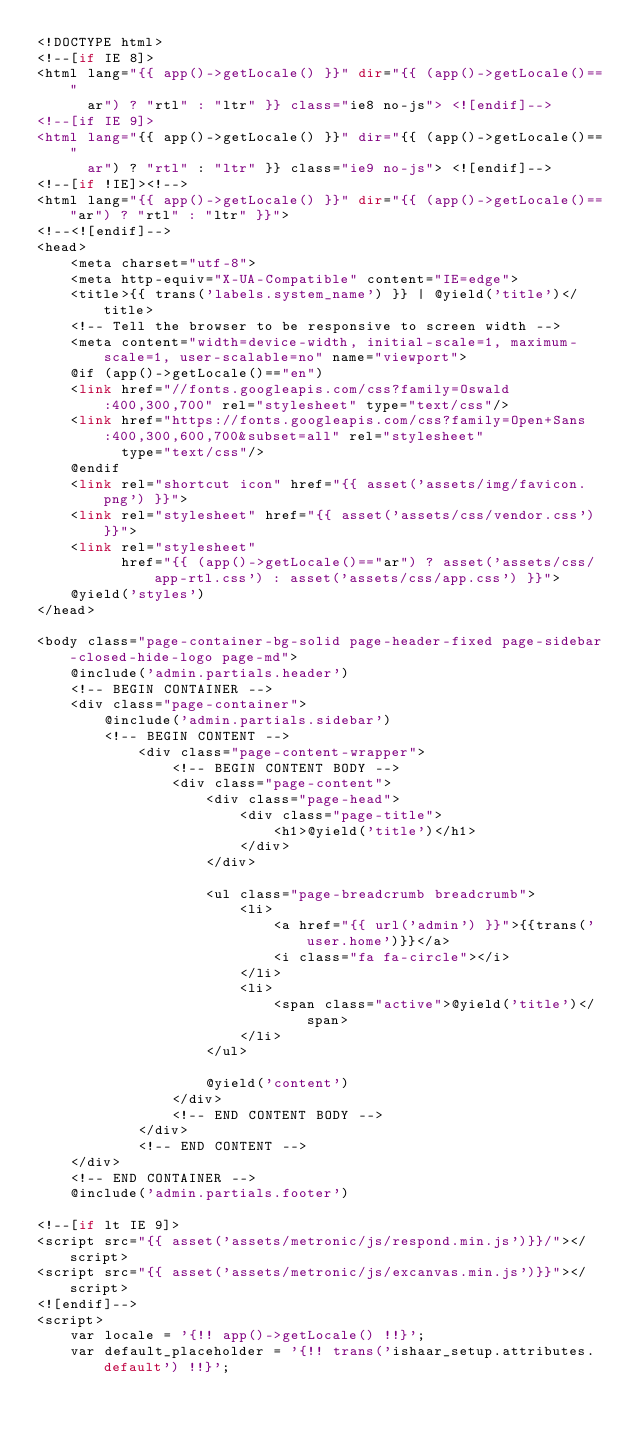<code> <loc_0><loc_0><loc_500><loc_500><_PHP_><!DOCTYPE html>
<!--[if IE 8]>
<html lang="{{ app()->getLocale() }}" dir="{{ (app()->getLocale()=="
      ar") ? "rtl" : "ltr" }} class="ie8 no-js"> <![endif]-->
<!--[if IE 9]>
<html lang="{{ app()->getLocale() }}" dir="{{ (app()->getLocale()=="
      ar") ? "rtl" : "ltr" }} class="ie9 no-js"> <![endif]-->
<!--[if !IE]><!-->
<html lang="{{ app()->getLocale() }}" dir="{{ (app()->getLocale()=="ar") ? "rtl" : "ltr" }}">
<!--<![endif]-->
<head>
    <meta charset="utf-8">
    <meta http-equiv="X-UA-Compatible" content="IE=edge">
    <title>{{ trans('labels.system_name') }} | @yield('title')</title>
    <!-- Tell the browser to be responsive to screen width -->
    <meta content="width=device-width, initial-scale=1, maximum-scale=1, user-scalable=no" name="viewport">
    @if (app()->getLocale()=="en")
    <link href="//fonts.googleapis.com/css?family=Oswald:400,300,700" rel="stylesheet" type="text/css"/>
    <link href="https://fonts.googleapis.com/css?family=Open+Sans:400,300,600,700&subset=all" rel="stylesheet"
          type="text/css"/>
    @endif
    <link rel="shortcut icon" href="{{ asset('assets/img/favicon.png') }}">
    <link rel="stylesheet" href="{{ asset('assets/css/vendor.css') }}">
    <link rel="stylesheet"
          href="{{ (app()->getLocale()=="ar") ? asset('assets/css/app-rtl.css') : asset('assets/css/app.css') }}">
    @yield('styles')
</head>

<body class="page-container-bg-solid page-header-fixed page-sidebar-closed-hide-logo page-md">
    @include('admin.partials.header')
    <!-- BEGIN CONTAINER -->
    <div class="page-container">
        @include('admin.partials.sidebar')
        <!-- BEGIN CONTENT -->
            <div class="page-content-wrapper">
                <!-- BEGIN CONTENT BODY -->
                <div class="page-content">
                    <div class="page-head">
                        <div class="page-title">
                            <h1>@yield('title')</h1>
                        </div>
                    </div>

                    <ul class="page-breadcrumb breadcrumb">
                        <li>
                            <a href="{{ url('admin') }}">{{trans('user.home')}}</a>
                            <i class="fa fa-circle"></i>
                        </li>
                        <li>
                            <span class="active">@yield('title')</span>
                        </li>
                    </ul>

                    @yield('content')
                </div>
                <!-- END CONTENT BODY -->
            </div>
            <!-- END CONTENT -->
    </div>
    <!-- END CONTAINER -->
    @include('admin.partials.footer')

<!--[if lt IE 9]>
<script src="{{ asset('assets/metronic/js/respond.min.js')}}/"></script>
<script src="{{ asset('assets/metronic/js/excanvas.min.js')}}"></script>
<![endif]-->
<script>
    var locale = '{!! app()->getLocale() !!}';
    var default_placeholder = '{!! trans('ishaar_setup.attributes.default') !!}';</code> 